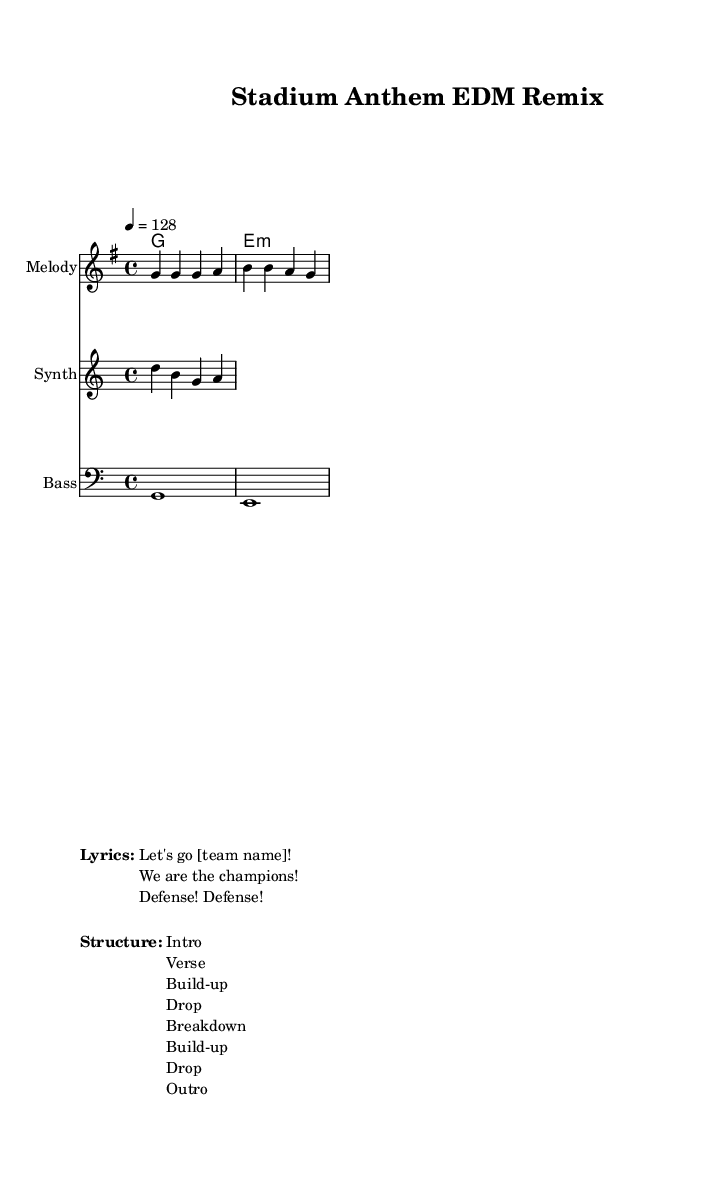What is the key signature of this music? The key signature is G major, which has one sharp (F#). This can be identified in the first bar of the music sheet where the G major is noted.
Answer: G major What is the time signature of this music? The time signature is 4/4, which means there are four beats in each measure and a quarter note receives one beat. This is indicated next to the clef at the beginning of the sheet music.
Answer: 4/4 What is the tempo marking in this music? The tempo marking is 128 beats per minute. This is stated in the tempo directive that appears in the global settings of the score, setting the speed for the piece.
Answer: 128 How many measures are in the melody section? There are two measures in the melody section, which is determined by counting the bar lines in the provided melody part of the score.
Answer: 2 What is the first line of the lyrics shown in the markup? The first line of the lyrics is "Let's go [team name]!" This is extracted from the list of lyrics provided in the markup section of the score.
Answer: "Let's go [team name]!" What section follows the first "Drop" in the structure? The section that follows the first "Drop" is the "Breakdown." This can be understood by looking at the structure list provided in the markup, which sequences the song's parts in order.
Answer: "Breakdown." What is the main role of the synth in this piece? The main role of the synth is to provide melodic support, as seen in the synth staff where the notes are designed to complement the overall energetic vibe. This gives the remix its distinctive sound and fills out the harmonic structure.
Answer: Melodic support 